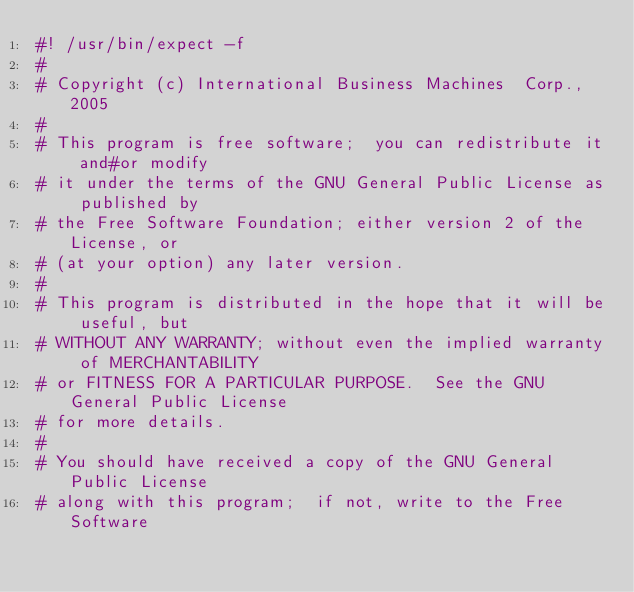<code> <loc_0><loc_0><loc_500><loc_500><_Bash_>#! /usr/bin/expect -f
#
# Copyright (c) International Business Machines  Corp., 2005
#
# This program is free software;  you can redistribute it and#or modify
# it under the terms of the GNU General Public License as published by
# the Free Software Foundation; either version 2 of the License, or
# (at your option) any later version.
#
# This program is distributed in the hope that it will be useful, but
# WITHOUT ANY WARRANTY; without even the implied warranty of MERCHANTABILITY
# or FITNESS FOR A PARTICULAR PURPOSE.  See the GNU General Public License
# for more details.
#
# You should have received a copy of the GNU General Public License
# along with this program;  if not, write to the Free Software</code> 